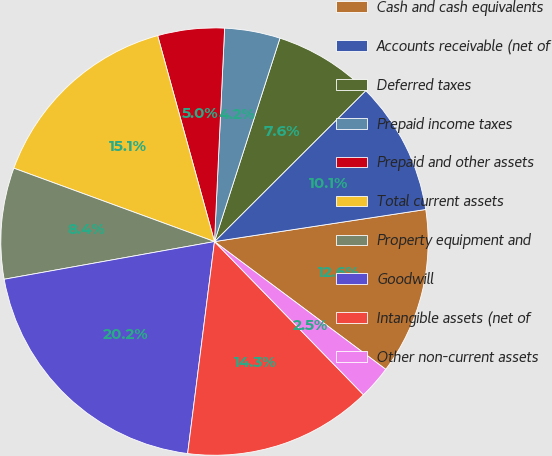Convert chart. <chart><loc_0><loc_0><loc_500><loc_500><pie_chart><fcel>Cash and cash equivalents<fcel>Accounts receivable (net of<fcel>Deferred taxes<fcel>Prepaid income taxes<fcel>Prepaid and other assets<fcel>Total current assets<fcel>Property equipment and<fcel>Goodwill<fcel>Intangible assets (net of<fcel>Other non-current assets<nl><fcel>12.6%<fcel>10.08%<fcel>7.56%<fcel>4.2%<fcel>5.04%<fcel>15.13%<fcel>8.4%<fcel>20.17%<fcel>14.28%<fcel>2.52%<nl></chart> 